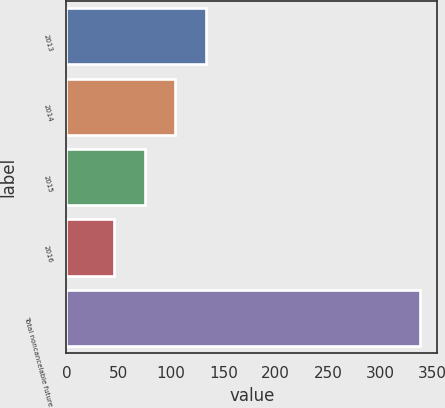Convert chart. <chart><loc_0><loc_0><loc_500><loc_500><bar_chart><fcel>2013<fcel>2014<fcel>2015<fcel>2016<fcel>Total noncancelable future<nl><fcel>133.23<fcel>104.02<fcel>74.81<fcel>45.6<fcel>337.7<nl></chart> 